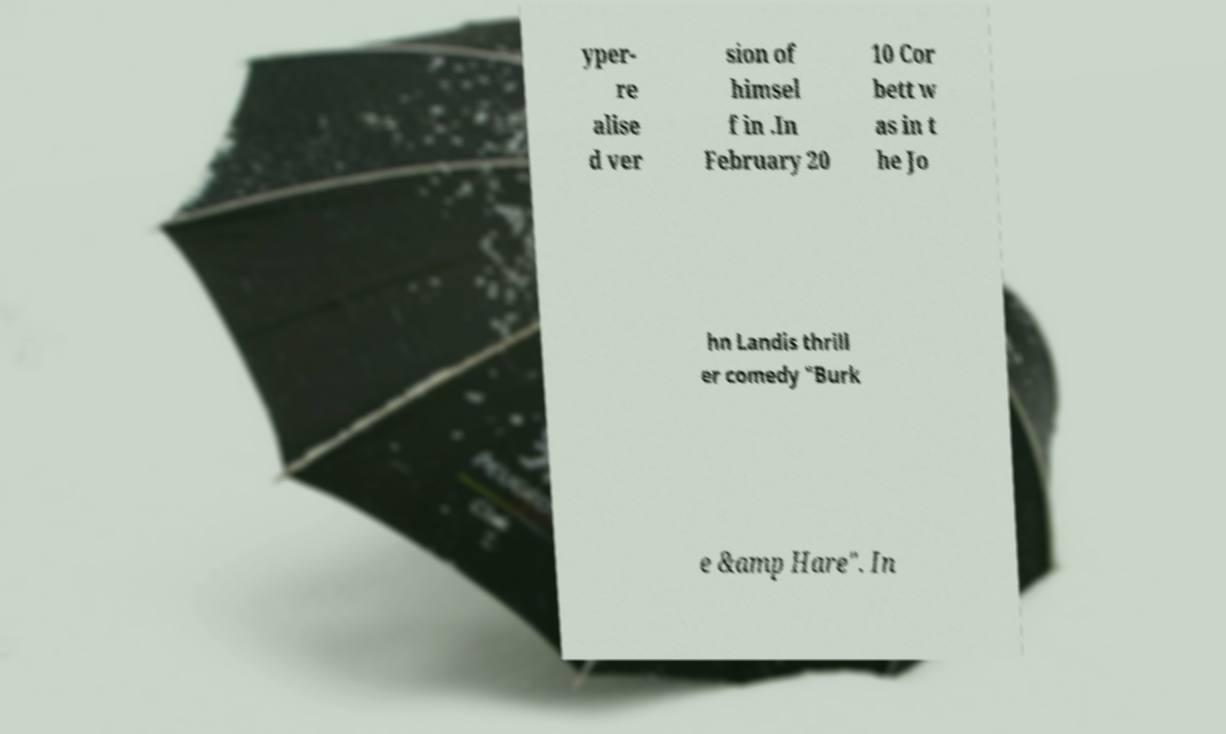Please identify and transcribe the text found in this image. yper- re alise d ver sion of himsel f in .In February 20 10 Cor bett w as in t he Jo hn Landis thrill er comedy "Burk e &amp Hare". In 